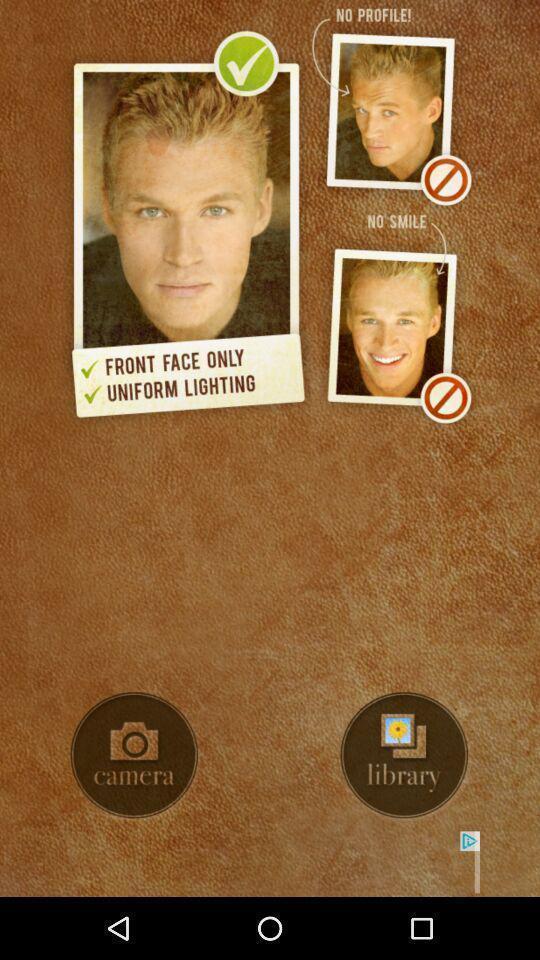Tell me what you see in this picture. Welcome interface for an image editing app. 